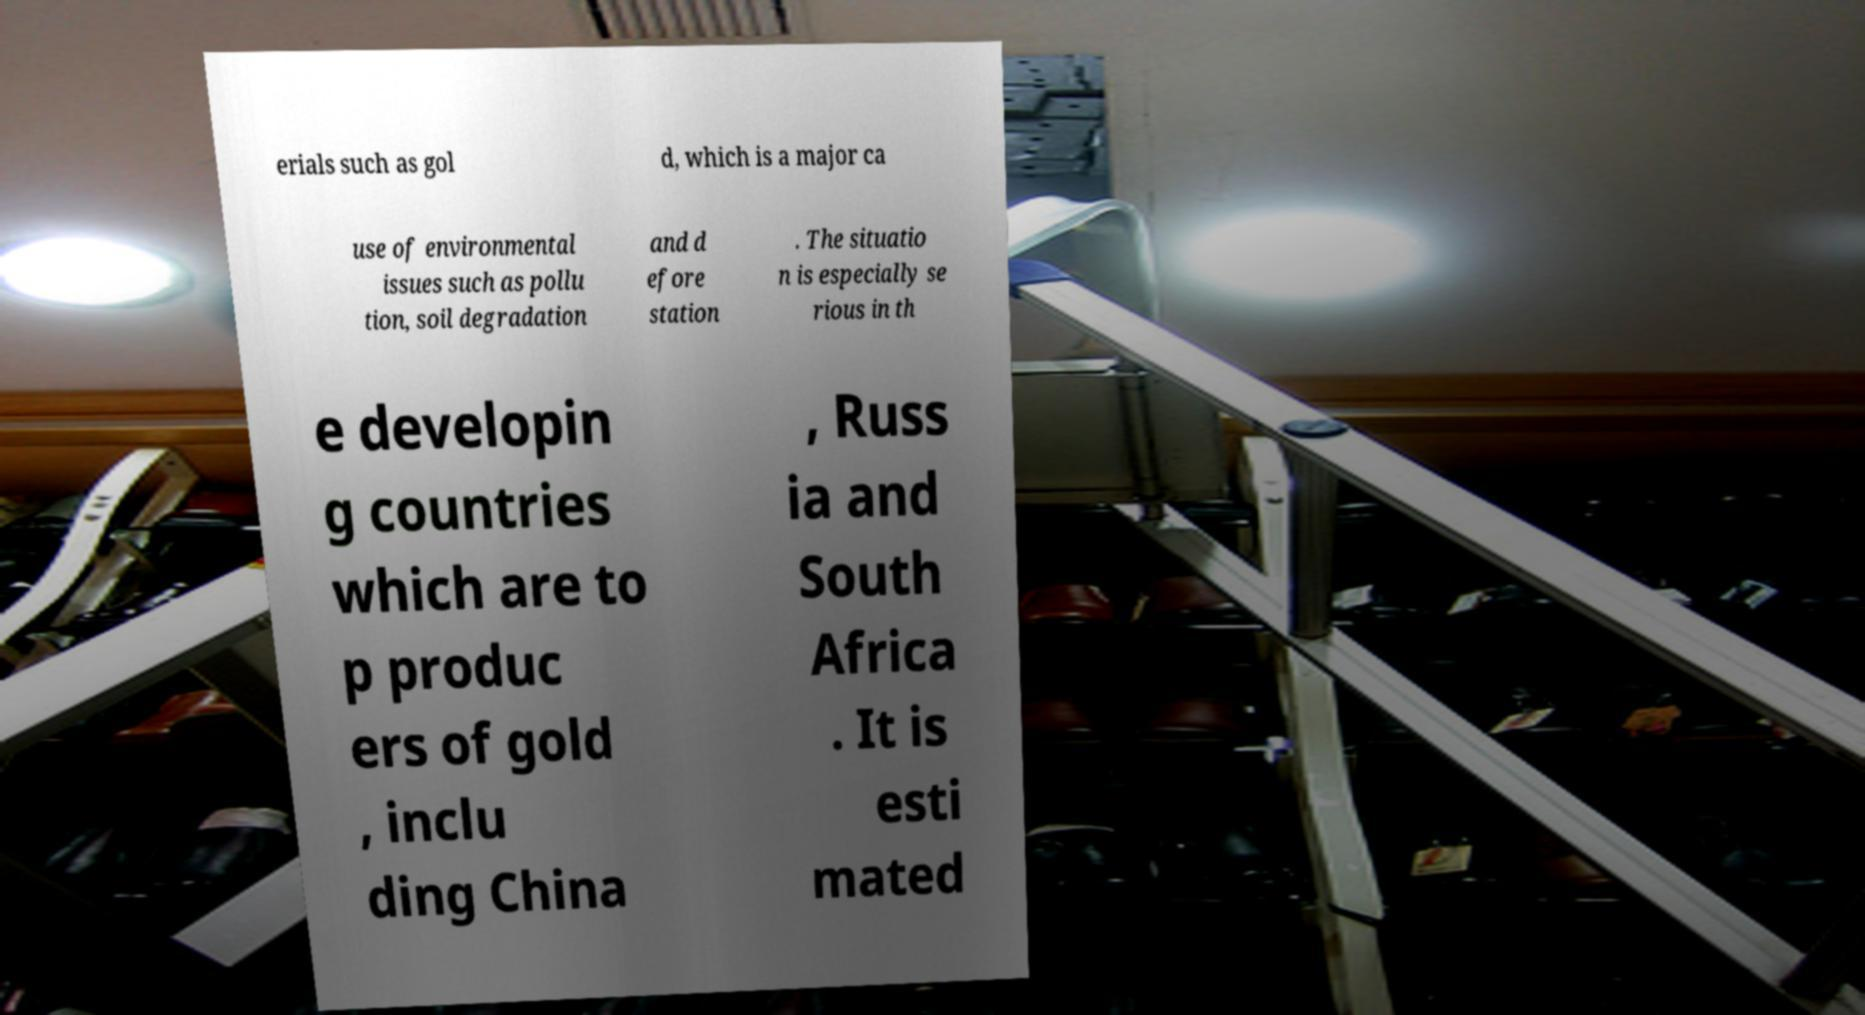I need the written content from this picture converted into text. Can you do that? erials such as gol d, which is a major ca use of environmental issues such as pollu tion, soil degradation and d efore station . The situatio n is especially se rious in th e developin g countries which are to p produc ers of gold , inclu ding China , Russ ia and South Africa . It is esti mated 